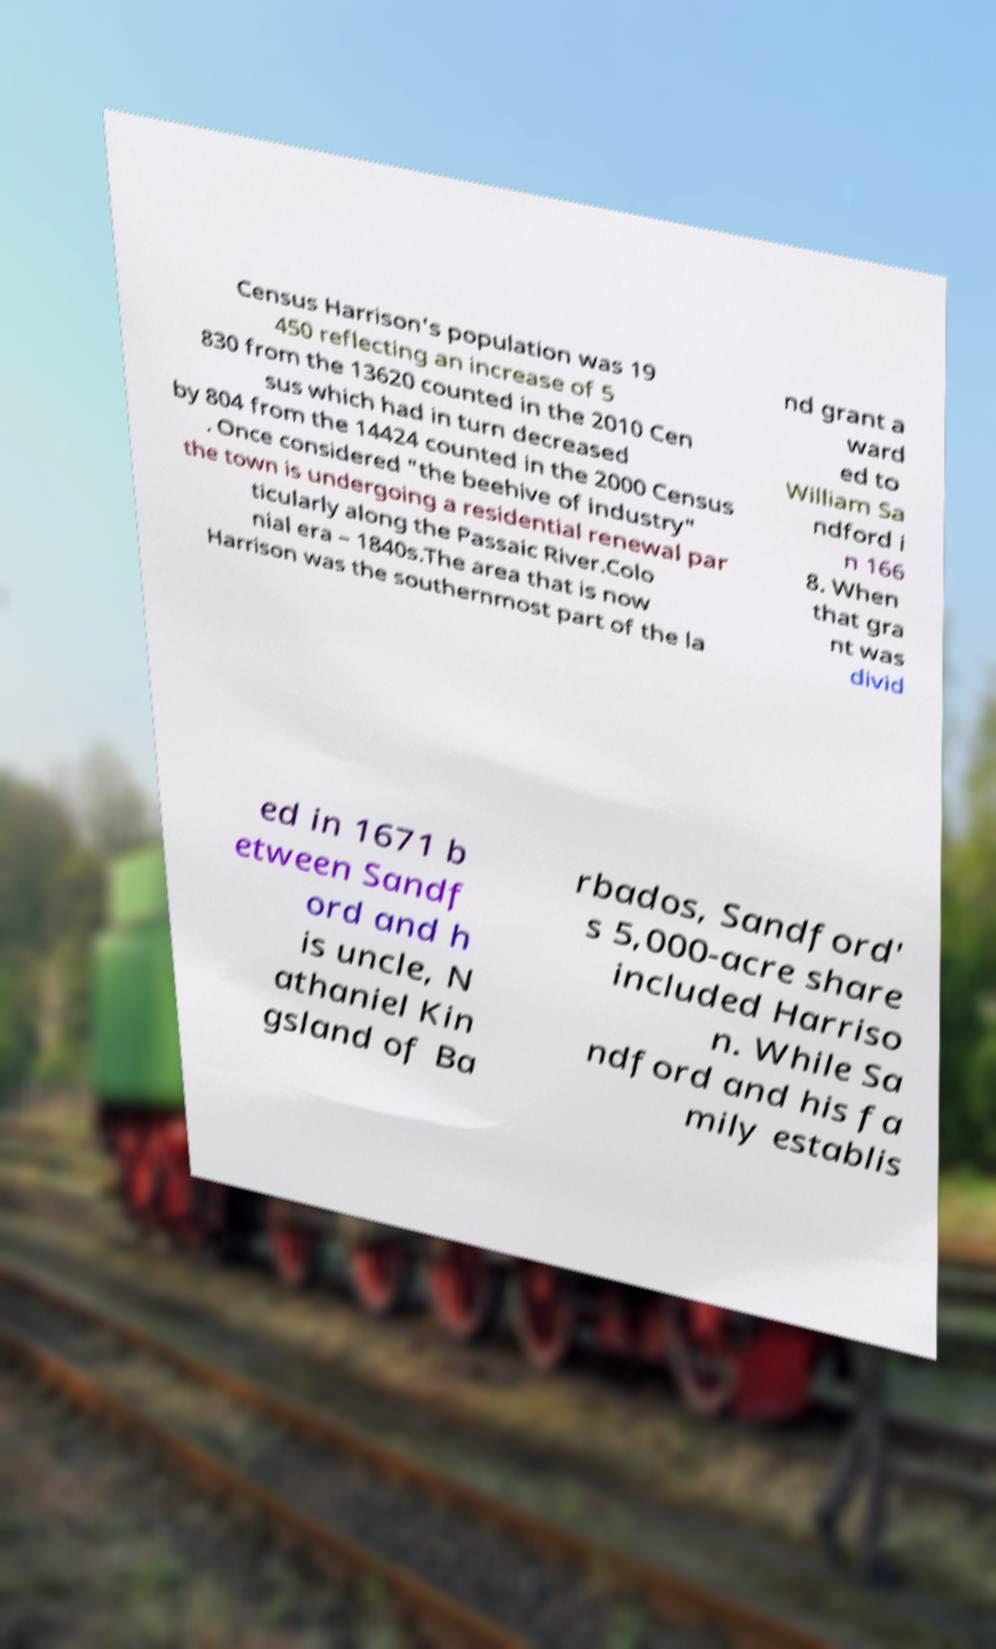Can you accurately transcribe the text from the provided image for me? Census Harrison's population was 19 450 reflecting an increase of 5 830 from the 13620 counted in the 2010 Cen sus which had in turn decreased by 804 from the 14424 counted in the 2000 Census . Once considered "the beehive of industry" the town is undergoing a residential renewal par ticularly along the Passaic River.Colo nial era – 1840s.The area that is now Harrison was the southernmost part of the la nd grant a ward ed to William Sa ndford i n 166 8. When that gra nt was divid ed in 1671 b etween Sandf ord and h is uncle, N athaniel Kin gsland of Ba rbados, Sandford' s 5,000-acre share included Harriso n. While Sa ndford and his fa mily establis 